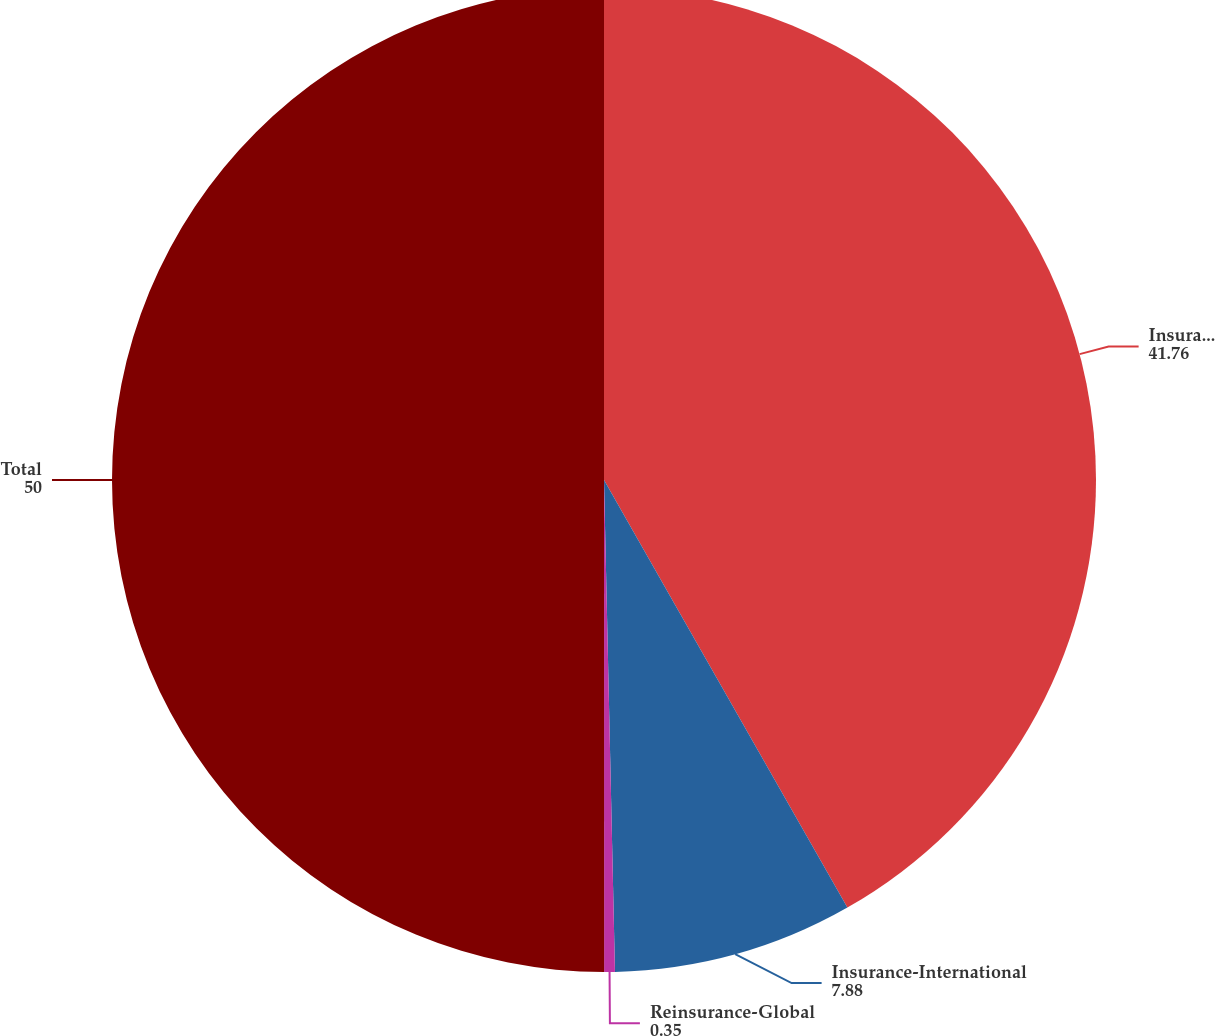<chart> <loc_0><loc_0><loc_500><loc_500><pie_chart><fcel>Insurance-Domestic<fcel>Insurance-International<fcel>Reinsurance-Global<fcel>Total<nl><fcel>41.76%<fcel>7.88%<fcel>0.35%<fcel>50.0%<nl></chart> 